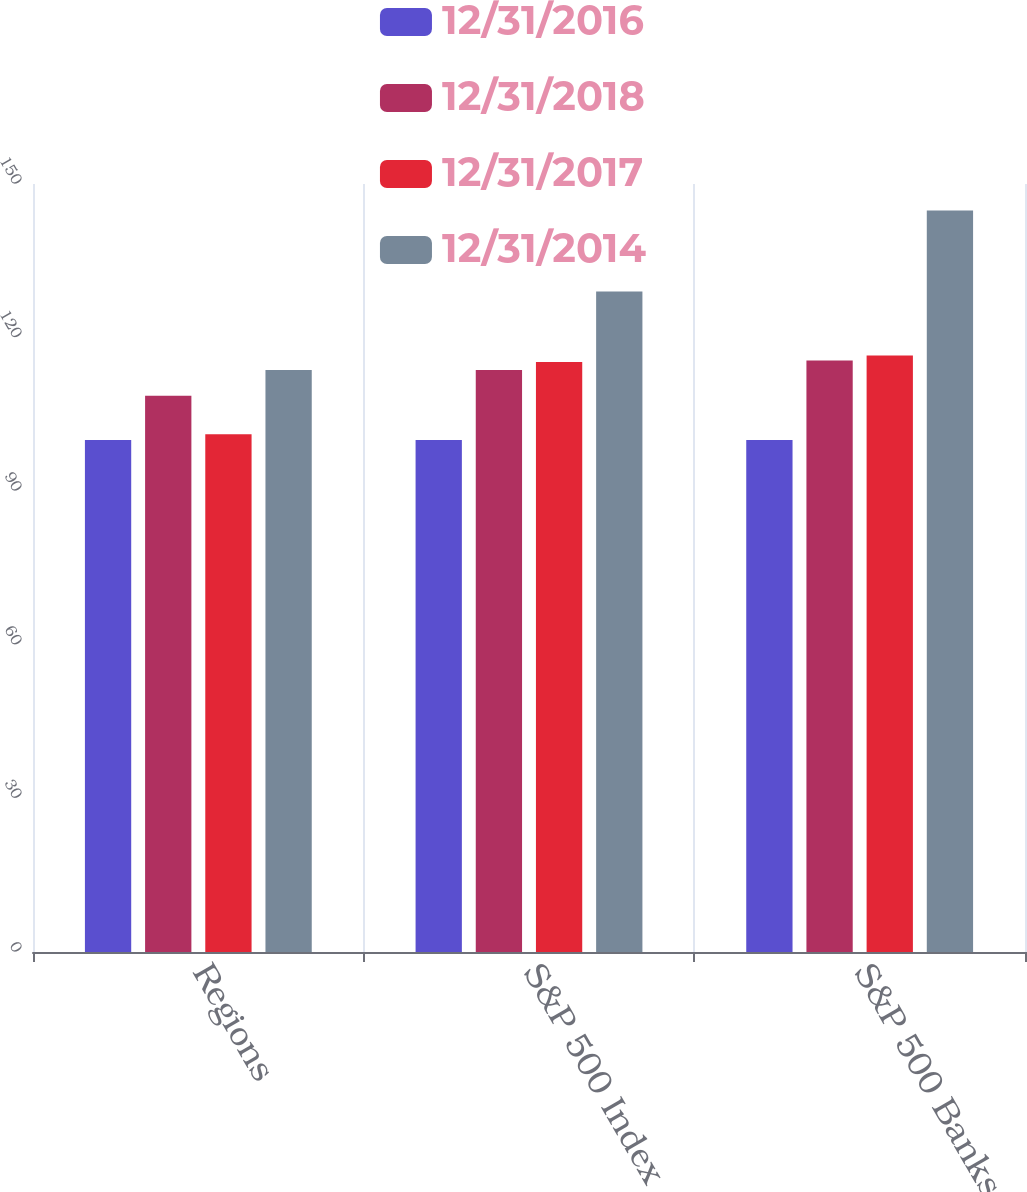<chart> <loc_0><loc_0><loc_500><loc_500><stacked_bar_chart><ecel><fcel>Regions<fcel>S&P 500 Index<fcel>S&P 500 Banks Index<nl><fcel>12/31/2016<fcel>100<fcel>100<fcel>100<nl><fcel>12/31/2018<fcel>108.63<fcel>113.68<fcel>115.51<nl><fcel>12/31/2017<fcel>101.11<fcel>115.24<fcel>116.49<nl><fcel>12/31/2014<fcel>113.68<fcel>129.02<fcel>144.81<nl></chart> 